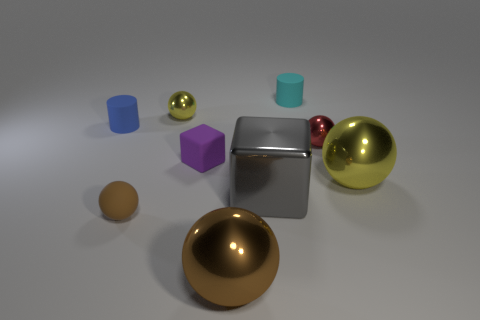The big metallic thing that is the same color as the small matte ball is what shape?
Your answer should be compact. Sphere. What size is the other sphere that is the same color as the matte ball?
Your answer should be very brief. Large. What material is the other tiny brown thing that is the same shape as the brown metal thing?
Provide a short and direct response. Rubber. There is a small thing on the left side of the tiny ball that is in front of the small red metal ball; what is its color?
Your response must be concise. Blue. Is the number of yellow spheres in front of the large gray block less than the number of yellow objects behind the purple object?
Give a very brief answer. Yes. What is the material of the large sphere that is the same color as the tiny matte ball?
Make the answer very short. Metal. What number of things are either things that are behind the tiny purple block or tiny cyan cylinders?
Make the answer very short. 4. Is the size of the yellow sphere that is in front of the purple cube the same as the purple matte block?
Your answer should be very brief. No. Is the number of tiny purple rubber cubes that are to the right of the tiny red thing less than the number of cylinders?
Give a very brief answer. Yes. What material is the purple block that is the same size as the red ball?
Make the answer very short. Rubber. 